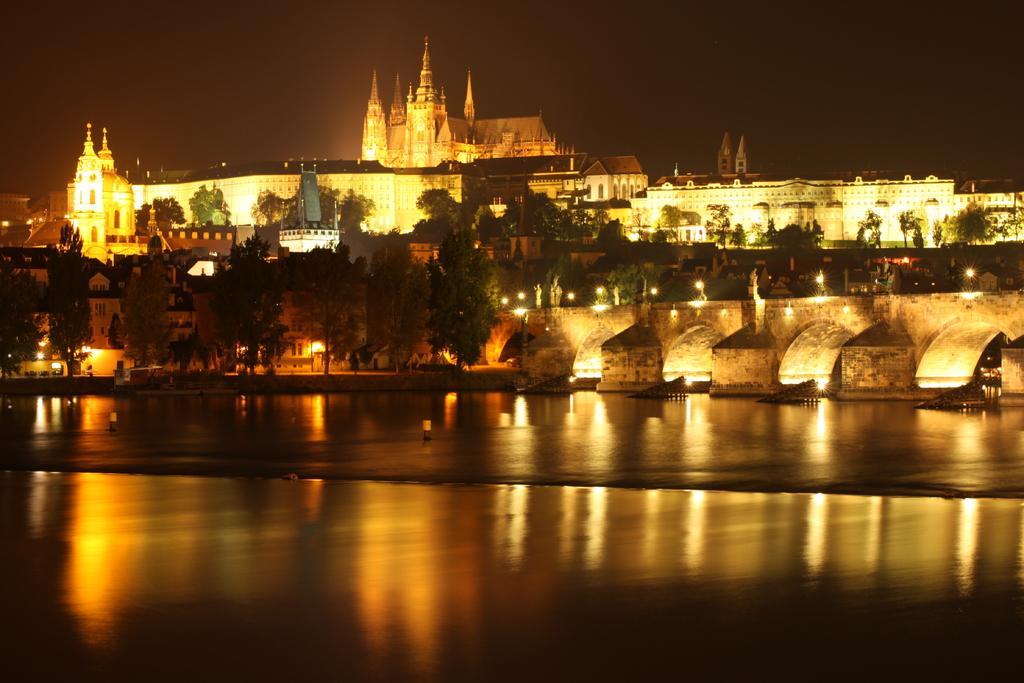What type of structures are present in the image? There are bungalows and buildings in the image. What other natural elements can be seen in the image? There are trees and water visible in the image. What man-made structure connects two areas in the image? There is a bridge in the image. What provides illumination in the image? There are lights in the image. What can be seen in the background of the image? The sky is visible in the background of the image. What type of notebook is being used by the trees in the image? There is no notebook present in the image, as it features bungalows, buildings, trees, a bridge, lights, water, and the sky. What is the pleasure level of the bungalows in the image? The pleasure level of the bungalows cannot be determined from the image, as they are inanimate structures. 